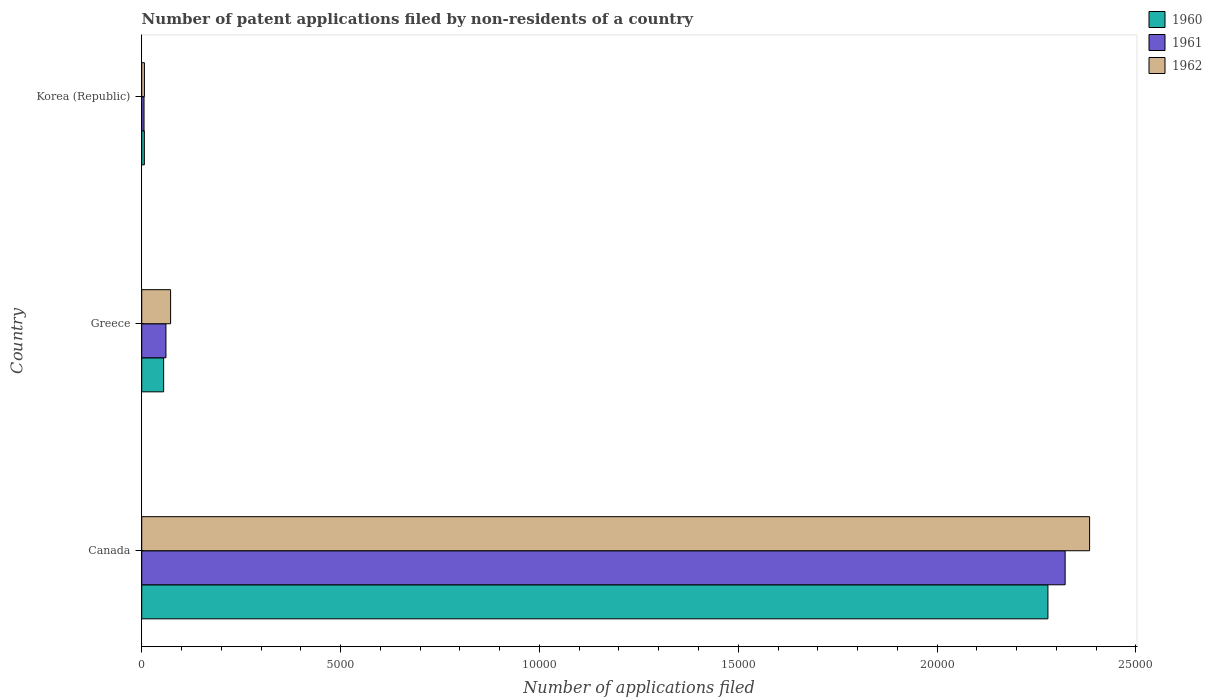How many different coloured bars are there?
Offer a very short reply. 3. Are the number of bars on each tick of the Y-axis equal?
Keep it short and to the point. Yes. How many bars are there on the 1st tick from the bottom?
Give a very brief answer. 3. What is the label of the 2nd group of bars from the top?
Your answer should be very brief. Greece. Across all countries, what is the maximum number of applications filed in 1960?
Keep it short and to the point. 2.28e+04. What is the total number of applications filed in 1960 in the graph?
Provide a short and direct response. 2.34e+04. What is the difference between the number of applications filed in 1961 in Canada and that in Korea (Republic)?
Keep it short and to the point. 2.32e+04. What is the difference between the number of applications filed in 1962 in Greece and the number of applications filed in 1961 in Canada?
Offer a very short reply. -2.25e+04. What is the average number of applications filed in 1961 per country?
Offer a very short reply. 7962. In how many countries, is the number of applications filed in 1960 greater than 22000 ?
Your answer should be compact. 1. What is the ratio of the number of applications filed in 1960 in Greece to that in Korea (Republic)?
Offer a terse response. 8.35. What is the difference between the highest and the second highest number of applications filed in 1962?
Provide a short and direct response. 2.31e+04. What is the difference between the highest and the lowest number of applications filed in 1962?
Make the answer very short. 2.38e+04. Is the sum of the number of applications filed in 1960 in Canada and Greece greater than the maximum number of applications filed in 1961 across all countries?
Offer a terse response. Yes. What does the 2nd bar from the top in Korea (Republic) represents?
Offer a terse response. 1961. What does the 2nd bar from the bottom in Greece represents?
Your answer should be compact. 1961. Are all the bars in the graph horizontal?
Your response must be concise. Yes. Does the graph contain grids?
Your answer should be compact. No. How are the legend labels stacked?
Provide a succinct answer. Vertical. What is the title of the graph?
Provide a succinct answer. Number of patent applications filed by non-residents of a country. What is the label or title of the X-axis?
Give a very brief answer. Number of applications filed. What is the Number of applications filed in 1960 in Canada?
Give a very brief answer. 2.28e+04. What is the Number of applications filed in 1961 in Canada?
Provide a short and direct response. 2.32e+04. What is the Number of applications filed of 1962 in Canada?
Your answer should be very brief. 2.38e+04. What is the Number of applications filed in 1960 in Greece?
Your answer should be very brief. 551. What is the Number of applications filed of 1961 in Greece?
Offer a terse response. 609. What is the Number of applications filed of 1962 in Greece?
Offer a very short reply. 726. What is the Number of applications filed of 1962 in Korea (Republic)?
Give a very brief answer. 68. Across all countries, what is the maximum Number of applications filed of 1960?
Your response must be concise. 2.28e+04. Across all countries, what is the maximum Number of applications filed of 1961?
Your answer should be compact. 2.32e+04. Across all countries, what is the maximum Number of applications filed of 1962?
Provide a short and direct response. 2.38e+04. Across all countries, what is the minimum Number of applications filed of 1962?
Make the answer very short. 68. What is the total Number of applications filed in 1960 in the graph?
Offer a very short reply. 2.34e+04. What is the total Number of applications filed of 1961 in the graph?
Keep it short and to the point. 2.39e+04. What is the total Number of applications filed of 1962 in the graph?
Provide a succinct answer. 2.46e+04. What is the difference between the Number of applications filed of 1960 in Canada and that in Greece?
Your answer should be compact. 2.22e+04. What is the difference between the Number of applications filed in 1961 in Canada and that in Greece?
Ensure brevity in your answer.  2.26e+04. What is the difference between the Number of applications filed in 1962 in Canada and that in Greece?
Your answer should be compact. 2.31e+04. What is the difference between the Number of applications filed in 1960 in Canada and that in Korea (Republic)?
Keep it short and to the point. 2.27e+04. What is the difference between the Number of applications filed in 1961 in Canada and that in Korea (Republic)?
Your response must be concise. 2.32e+04. What is the difference between the Number of applications filed of 1962 in Canada and that in Korea (Republic)?
Make the answer very short. 2.38e+04. What is the difference between the Number of applications filed of 1960 in Greece and that in Korea (Republic)?
Offer a terse response. 485. What is the difference between the Number of applications filed in 1961 in Greece and that in Korea (Republic)?
Provide a short and direct response. 551. What is the difference between the Number of applications filed of 1962 in Greece and that in Korea (Republic)?
Offer a terse response. 658. What is the difference between the Number of applications filed of 1960 in Canada and the Number of applications filed of 1961 in Greece?
Your answer should be very brief. 2.22e+04. What is the difference between the Number of applications filed of 1960 in Canada and the Number of applications filed of 1962 in Greece?
Your response must be concise. 2.21e+04. What is the difference between the Number of applications filed in 1961 in Canada and the Number of applications filed in 1962 in Greece?
Your answer should be compact. 2.25e+04. What is the difference between the Number of applications filed of 1960 in Canada and the Number of applications filed of 1961 in Korea (Republic)?
Give a very brief answer. 2.27e+04. What is the difference between the Number of applications filed of 1960 in Canada and the Number of applications filed of 1962 in Korea (Republic)?
Provide a short and direct response. 2.27e+04. What is the difference between the Number of applications filed of 1961 in Canada and the Number of applications filed of 1962 in Korea (Republic)?
Give a very brief answer. 2.32e+04. What is the difference between the Number of applications filed of 1960 in Greece and the Number of applications filed of 1961 in Korea (Republic)?
Your response must be concise. 493. What is the difference between the Number of applications filed in 1960 in Greece and the Number of applications filed in 1962 in Korea (Republic)?
Offer a terse response. 483. What is the difference between the Number of applications filed of 1961 in Greece and the Number of applications filed of 1962 in Korea (Republic)?
Make the answer very short. 541. What is the average Number of applications filed of 1960 per country?
Make the answer very short. 7801. What is the average Number of applications filed of 1961 per country?
Offer a very short reply. 7962. What is the average Number of applications filed in 1962 per country?
Your response must be concise. 8209.33. What is the difference between the Number of applications filed in 1960 and Number of applications filed in 1961 in Canada?
Provide a succinct answer. -433. What is the difference between the Number of applications filed in 1960 and Number of applications filed in 1962 in Canada?
Give a very brief answer. -1048. What is the difference between the Number of applications filed in 1961 and Number of applications filed in 1962 in Canada?
Your response must be concise. -615. What is the difference between the Number of applications filed of 1960 and Number of applications filed of 1961 in Greece?
Offer a very short reply. -58. What is the difference between the Number of applications filed in 1960 and Number of applications filed in 1962 in Greece?
Your answer should be very brief. -175. What is the difference between the Number of applications filed in 1961 and Number of applications filed in 1962 in Greece?
Provide a short and direct response. -117. What is the difference between the Number of applications filed of 1960 and Number of applications filed of 1961 in Korea (Republic)?
Provide a short and direct response. 8. What is the difference between the Number of applications filed of 1960 and Number of applications filed of 1962 in Korea (Republic)?
Your answer should be very brief. -2. What is the difference between the Number of applications filed of 1961 and Number of applications filed of 1962 in Korea (Republic)?
Give a very brief answer. -10. What is the ratio of the Number of applications filed in 1960 in Canada to that in Greece?
Provide a succinct answer. 41.35. What is the ratio of the Number of applications filed in 1961 in Canada to that in Greece?
Your answer should be very brief. 38.13. What is the ratio of the Number of applications filed of 1962 in Canada to that in Greece?
Keep it short and to the point. 32.83. What is the ratio of the Number of applications filed of 1960 in Canada to that in Korea (Republic)?
Your answer should be very brief. 345.24. What is the ratio of the Number of applications filed in 1961 in Canada to that in Korea (Republic)?
Keep it short and to the point. 400.33. What is the ratio of the Number of applications filed of 1962 in Canada to that in Korea (Republic)?
Ensure brevity in your answer.  350.5. What is the ratio of the Number of applications filed of 1960 in Greece to that in Korea (Republic)?
Your answer should be compact. 8.35. What is the ratio of the Number of applications filed of 1962 in Greece to that in Korea (Republic)?
Offer a terse response. 10.68. What is the difference between the highest and the second highest Number of applications filed in 1960?
Your answer should be compact. 2.22e+04. What is the difference between the highest and the second highest Number of applications filed in 1961?
Your answer should be compact. 2.26e+04. What is the difference between the highest and the second highest Number of applications filed of 1962?
Your answer should be compact. 2.31e+04. What is the difference between the highest and the lowest Number of applications filed in 1960?
Offer a terse response. 2.27e+04. What is the difference between the highest and the lowest Number of applications filed of 1961?
Provide a succinct answer. 2.32e+04. What is the difference between the highest and the lowest Number of applications filed in 1962?
Provide a succinct answer. 2.38e+04. 